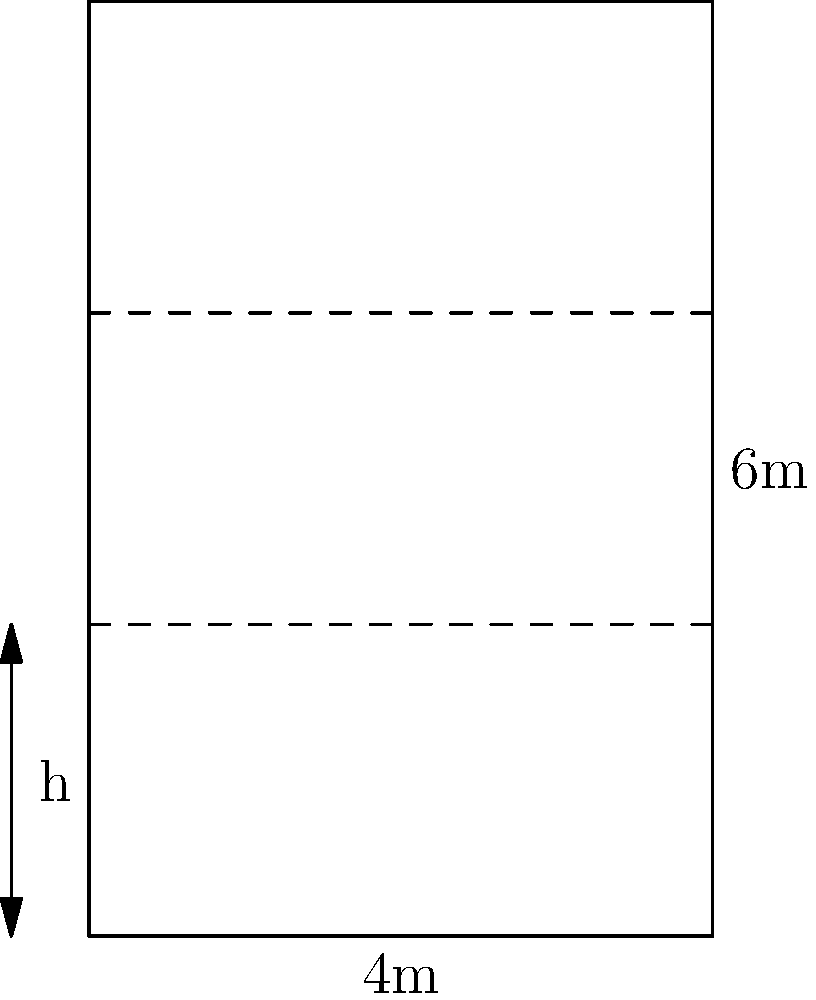A biotech company is designing a server rack to store their research data. The rack has a fixed width of 4 meters and a height of 6 meters. They want to divide the rack into equal-height compartments to house individual servers. If each server requires a minimum of 0.5 square meters of surface area for ventilation on its front face, what is the maximum number of servers that can be installed in the rack while meeting the ventilation requirement? Express your answer in terms of the floor function $\lfloor x \rfloor$, which gives the largest integer less than or equal to $x$. Let's approach this step-by-step:

1) The rack has a fixed width ($w$) of 4 meters and a height ($H$) of 6 meters.

2) Let $n$ be the number of servers (and thus compartments) in the rack.

3) The height of each compartment ($h$) will be:
   $h = \frac{H}{n} = \frac{6}{n}$ meters

4) The front face area of each compartment is:
   $A = w \cdot h = 4 \cdot \frac{6}{n} = \frac{24}{n}$ square meters

5) We need this area to be at least 0.5 square meters:
   $\frac{24}{n} \geq 0.5$

6) Solving for $n$:
   $n \leq 48$

7) Since $n$ must be an integer, and we want the maximum number of servers, we use the floor function:
   $n = \lfloor 48 \rfloor = 48$

Therefore, the maximum number of servers that can be installed while meeting the ventilation requirement is 48.
Answer: $\lfloor 48 \rfloor$ 